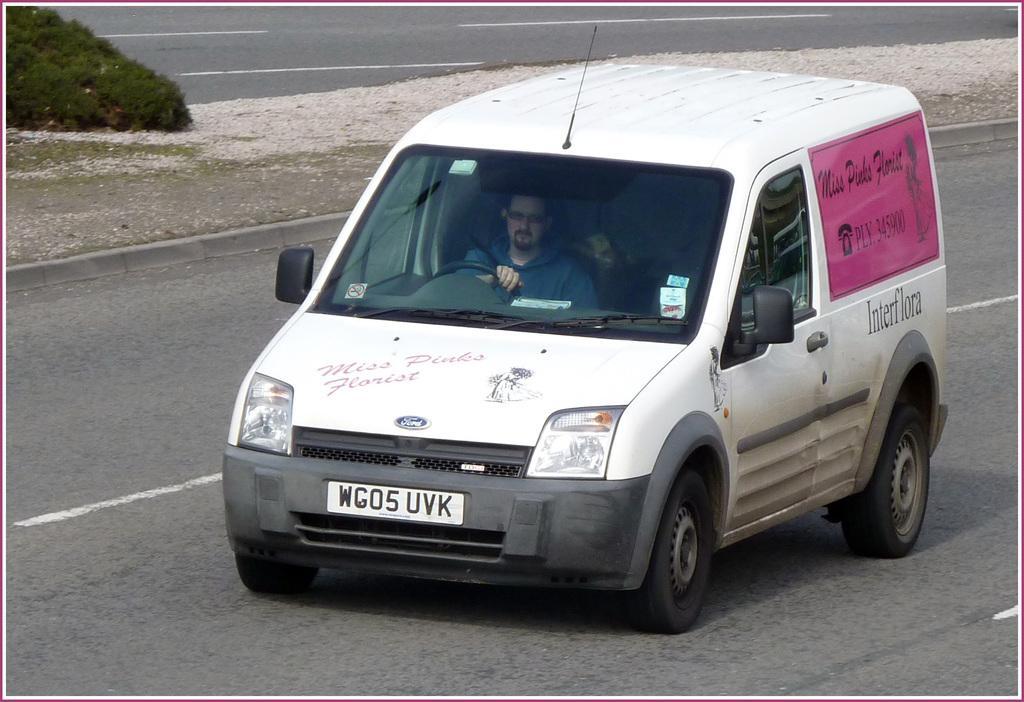Could you give a brief overview of what you see in this image? In this picture i can see a white color car moving on the road and we see a man driving the car and we see text on the car and a plant on the side 